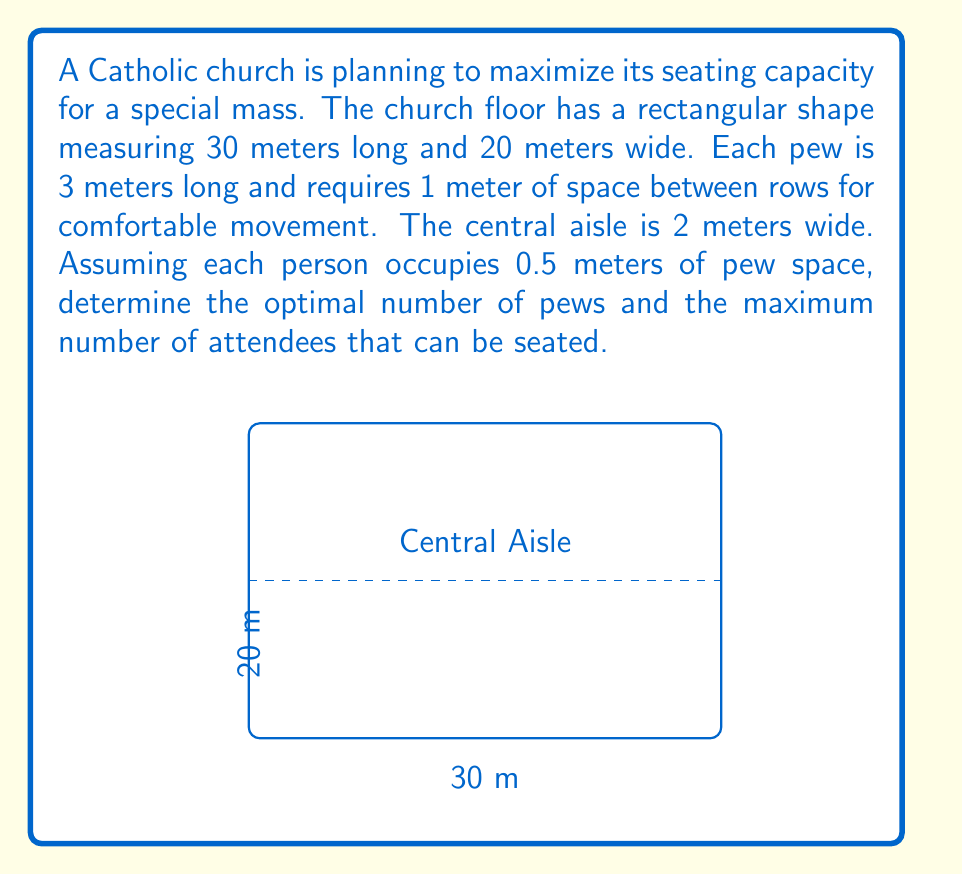Show me your answer to this math problem. Let's approach this problem step-by-step:

1) First, we need to calculate the available width for pews on each side of the central aisle:
   $$(20 \text{ m} - 2 \text{ m}) / 2 = 9 \text{ m}$$

2) Now, we need to determine how many rows of pews can fit in the 30-meter length:
   - Each pew requires 1 meter of space behind it
   - So each row effectively occupies 1 meter
   - Number of rows = $30 \text{ m} / 1 \text{ m} = 30$ rows

3) Calculate the number of pews:
   - 30 rows on each side of the aisle
   - Total number of pews = $30 \times 2 = 60$ pews

4) Calculate the seating capacity of each pew:
   - Each pew is 3 meters long
   - Each person occupies 0.5 meters
   - Capacity per pew = $3 \text{ m} / 0.5 \text{ m/person} = 6$ persons/pew

5) Calculate the total seating capacity:
   - Total capacity = Number of pews × Capacity per pew
   - Total capacity = $60 \times 6 = 360$ persons

Therefore, the optimal arrangement is 60 pews (30 on each side of the aisle), which can seat a maximum of 360 attendees.
Answer: 60 pews; 360 attendees 